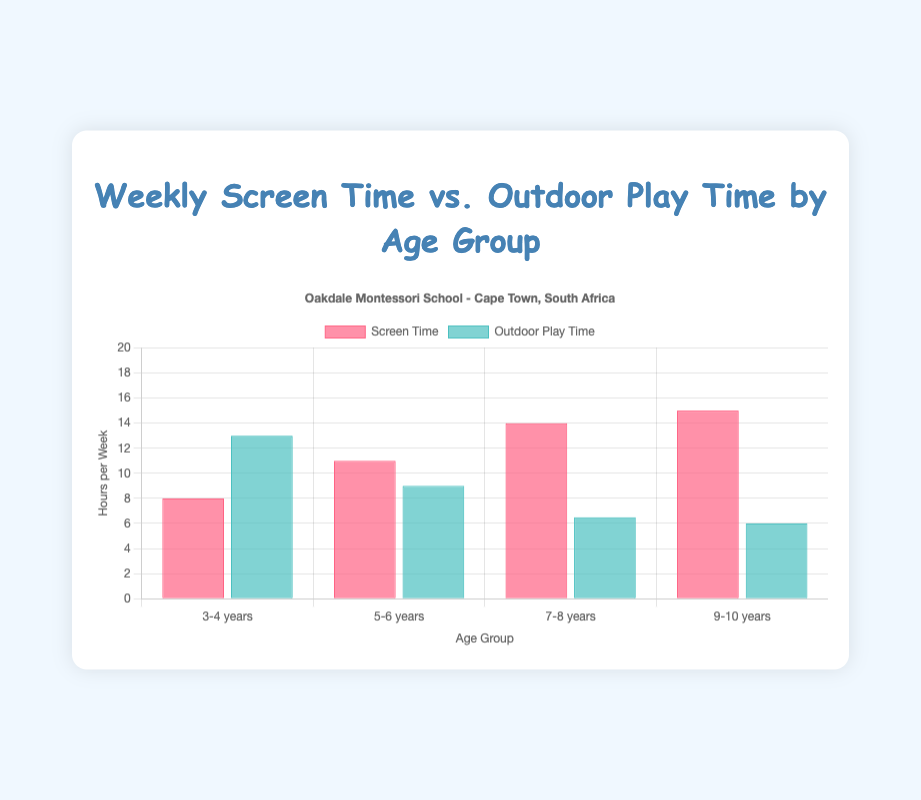What is the average weekly screen time for the 9-10 years age group? We have two data points for the 9-10 years age group: 16 and 14 hours. The average is calculated as (16 + 14) / 2 = 15 hours
Answer: 15 hours Which age group spends the most time on outdoor play on average? We need to compare the average outdoor play hours for each age group. 3-4 years: (14 + 12) / 2 = 13, 5-6 years: (10 + 8) / 2 = 9, 7-8 years: (6 + 7) / 2 = 6.5, 9-10 years: (5 + 7) / 2 = 6. Therefore, 3-4 years has the highest value of 13 hours on average
Answer: 3-4 years How much more outdoor play time does the 3-4 years age group get compared to the 5-6 years age group? The average outdoor play time for 3-4 years is 13 hours, and for 5-6 years, it is 9 hours. The difference is 13 - 9 = 4 hours
Answer: 4 hours Which age group has the highest average screen time? To find this, compare the average screen time for each age group. 3-4 years: (7 + 9) / 2 = 8, 5-6 years: (10 + 12) / 2 = 11, 7-8 years: (15 + 13) / 2 = 14, 9-10 years: (16 + 14) / 2 = 15. Therefore, 9-10 years has the highest value of 15 hours on average
Answer: 9-10 years Between the age groups 7-8 years and 9-10 years, which spends more time on outdoor play? For 7-8 years: (6 + 7) / 2 = 6.5 hours, and for 9-10 years: (5 + 7) / 2 = 6 hours. So, the 7-8 years age group spends more time on average
Answer: 7-8 years How does the screen time for the 3-4 years age group compare to the 7-8 years age group based on the figure? The average screen time for 3-4 years is 8 hours, while for 7-8 years, it is 14 hours. Therefore, the 7-8 years age group has significantly higher average screen time
Answer: Significantly higher What is the total weekly outdoor play time for all age groups combined? Sum all the average outdoor play times: 3-4 years: 13, 5-6 years: 9, 7-8 years: 6.5, 9-10 years: 6. The total is 13 + 9 + 6.5 + 6 = 34.5 hours
Answer: 34.5 hours Which dataset (screen time or outdoor play time) shows a consistent trend across age groups? Screen time generally increases with age (3-4 years: 8, 5-6 years: 11, 7-8 years: 14, 9-10 years: 15), whereas outdoor play decreases (3-4 years: 13, 5-6 years: 9, 7-8 years: 6.5, 9-10 years: 6). The consistent trend of increase is observed for screen time
Answer: Screen time How does the total average outdoor play time for all age groups compare to their screen time? Sum the averages for screen time: 3-4 years: 8, 5-6 years: 11, 7-8 years: 14, 9-10 years: 15. The total is 8 + 11 + 14 + 15 = 48. Then, for outdoor play, the total is 34.5. The screen time total is higher by 48 - 34.5 = 13.5 hours
Answer: Screen time is higher by 13.5 hours 